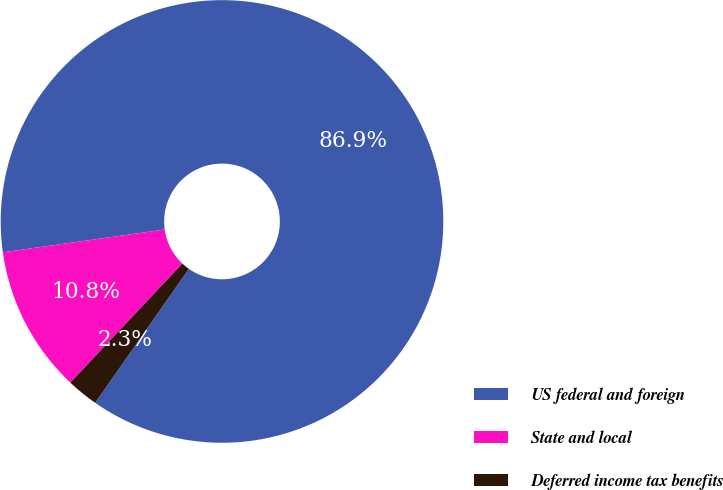<chart> <loc_0><loc_0><loc_500><loc_500><pie_chart><fcel>US federal and foreign<fcel>State and local<fcel>Deferred income tax benefits<nl><fcel>86.94%<fcel>10.76%<fcel>2.3%<nl></chart> 